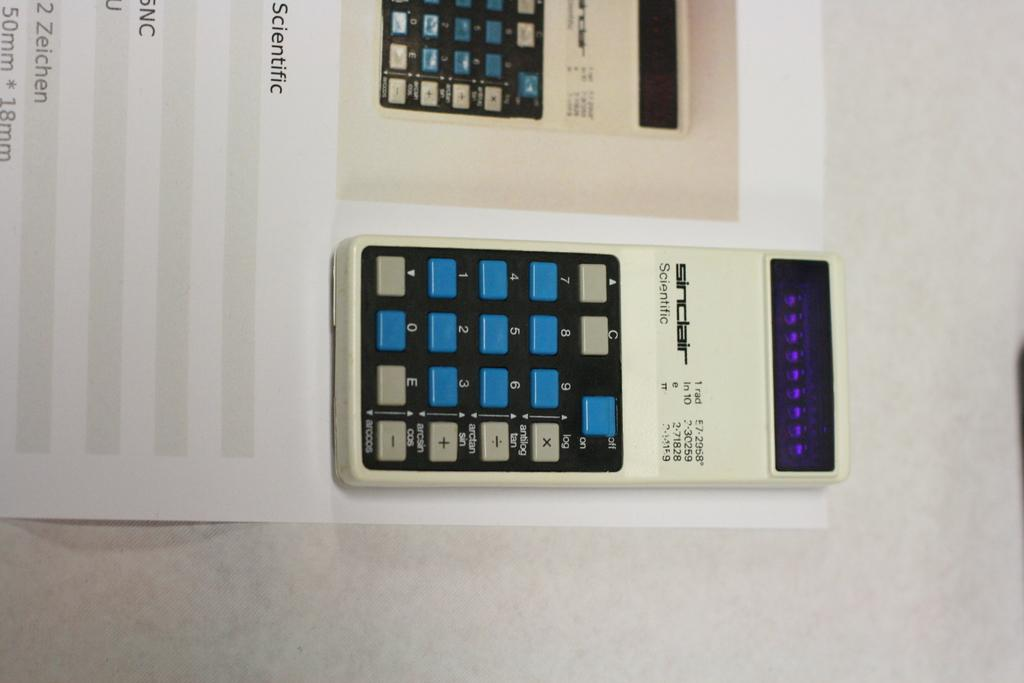<image>
Present a compact description of the photo's key features. a white sinclair key pad sitting on top of the instructions page. 